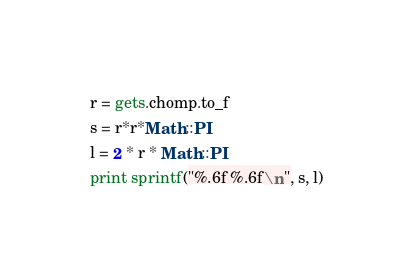Convert code to text. <code><loc_0><loc_0><loc_500><loc_500><_Ruby_>r = gets.chomp.to_f
s = r*r*Math::PI
l = 2 * r * Math::PI
print sprintf("%.6f %.6f\n", s, l)</code> 